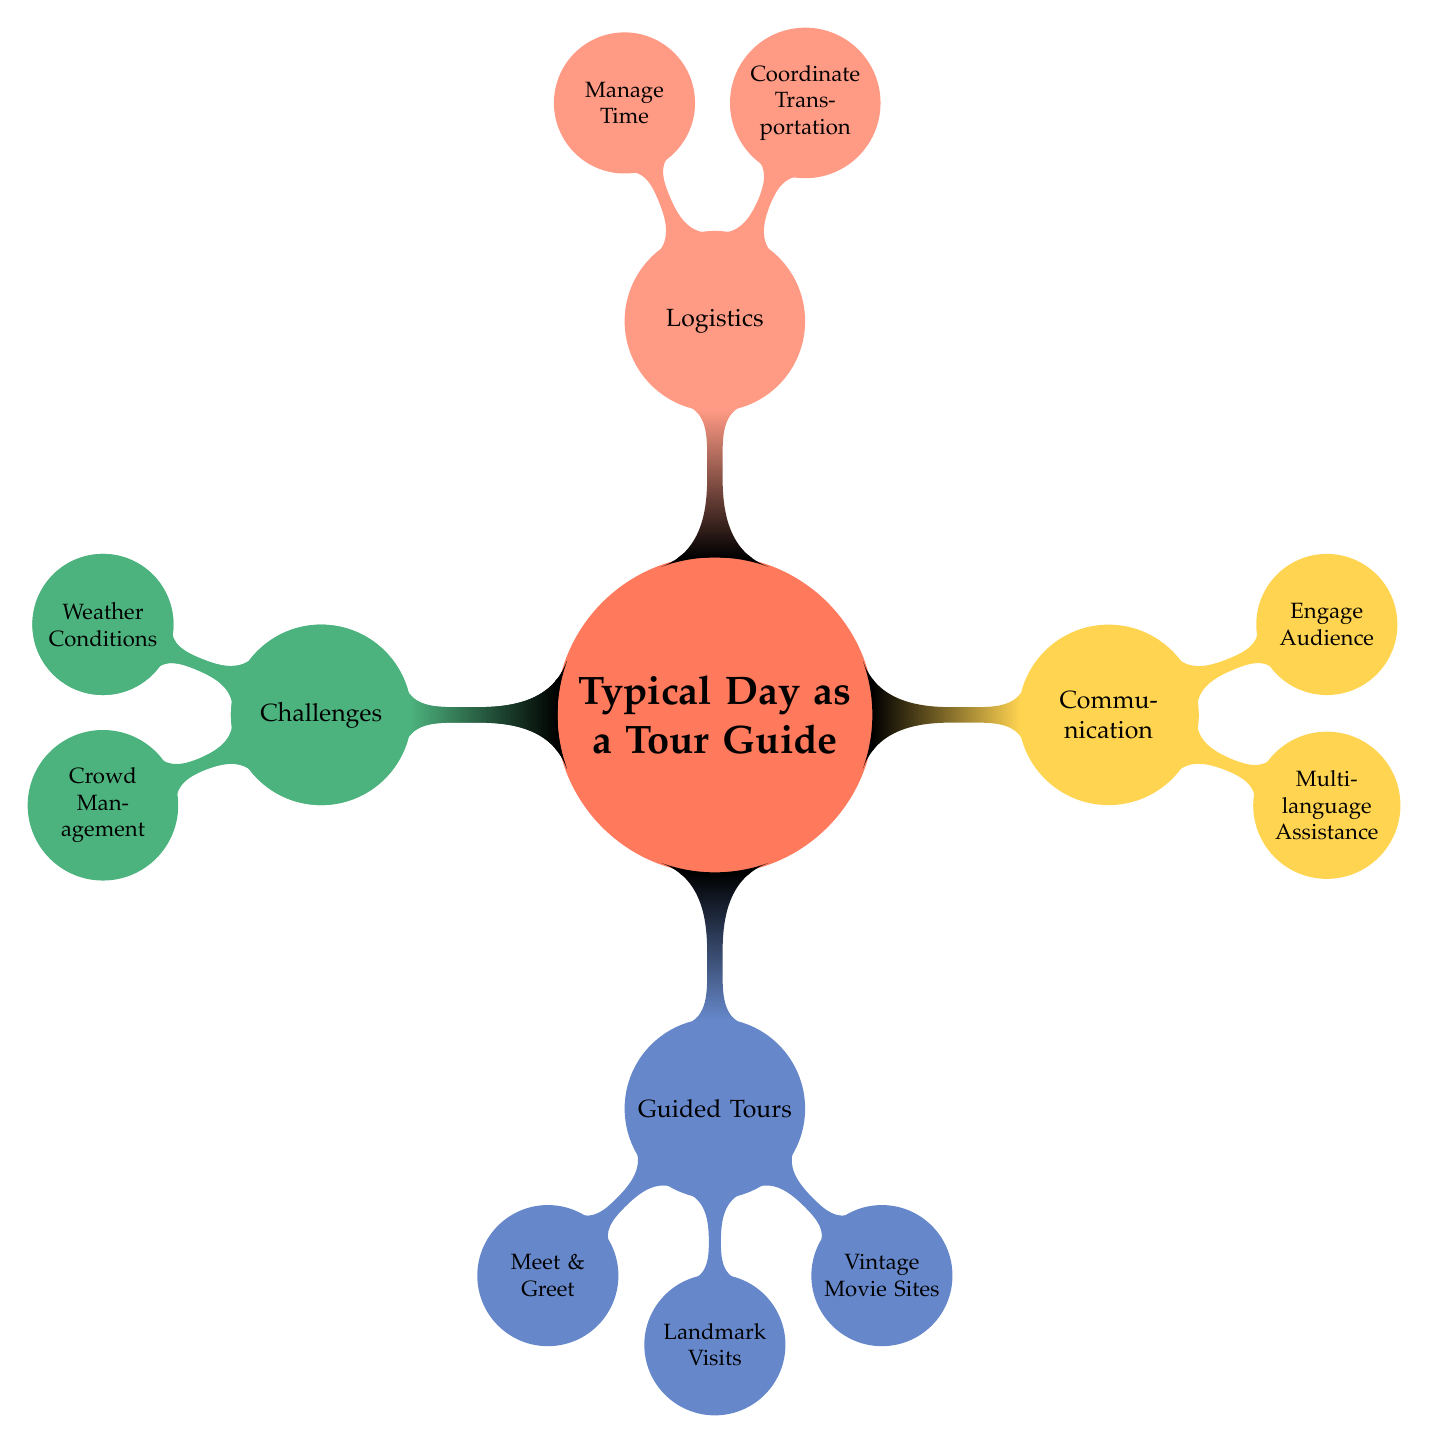What is one task included in the 'Preparation' category? In the 'Preparation' category, one of the tasks is to 'Create Itinerary.' This can be found as a child node under 'Preparation.'
Answer: Create Itinerary How many main categories are there in the diagram? The main categories are 'Preparation,' 'Guided Tours,' 'Communication,' 'Logistics,' and 'Challenges.' By counting these top-level nodes, we see there are five main categories.
Answer: 5 What should a tour guide do during 'Meet & Greet'? According to the 'Guided Tours' section, during 'Meet & Greet,' the tour guide should 'Welcome tourists, introduce self.' This is a specific task mentioned under that node.
Answer: Welcome tourists, introduce self Which category includes 'Engage Audience'? 'Engage Audience' is a task listed under the 'Communication' category. This node is connected as a child node to 'Communication.'
Answer: Communication What is a challenge a tour guide faces related to weather? Under the 'Challenges' category, one of the challenges mentioned is 'Weather Conditions.' This indicates the specific issue tour guides need to be prepared for.
Answer: Weather Conditions How do 'Coordinate Transportation' and 'Manage Time' relate to each other? Both 'Coordinate Transportation' and 'Manage Time' are tasks under the 'Logistics' category, indicating they are part of the same overarching responsibility for a tour guide to ensure smooth operations during tours.
Answer: Logistics What types of assistance is offered under 'Multi-language Assistance'? The 'Multi-language Assistance' node specifies that tour guides provide assistance in 'Italian, English, and basic Spanish.' This detail outlines the languages offered for communication during tours.
Answer: Italian, English, and basic Spanish How do vintage movie sites enhance tours? The inclusion of 'Vintage Movie Sites' as a task under 'Guided Tours' suggests they enhance the tours by adding a unique cultural and entertainment perspective related to classic films like 'Roman Holiday' and 'La Dolce Vita.'
Answer: Unique cultural perspective What kind of tours can the guide co-ordinate related to 'Transportation'? Under 'Logistics,' the task 'Coordinate Transportation' implies that the guide can arrange for 'bus or walking tours' as a means of transporting tourists to different locations.
Answer: Bus or walking tours 